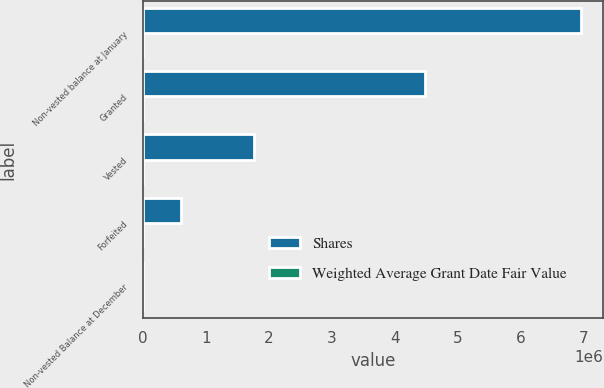Convert chart to OTSL. <chart><loc_0><loc_0><loc_500><loc_500><stacked_bar_chart><ecel><fcel>Non-vested balance at January<fcel>Granted<fcel>Vested<fcel>Forfeited<fcel>Non-vested Balance at December<nl><fcel>Shares<fcel>6.9604e+06<fcel>4.47851e+06<fcel>1.76489e+06<fcel>606156<fcel>48.43<nl><fcel>Weighted Average Grant Date Fair Value<fcel>44.95<fcel>29.88<fcel>48.43<fcel>40.27<fcel>37.14<nl></chart> 